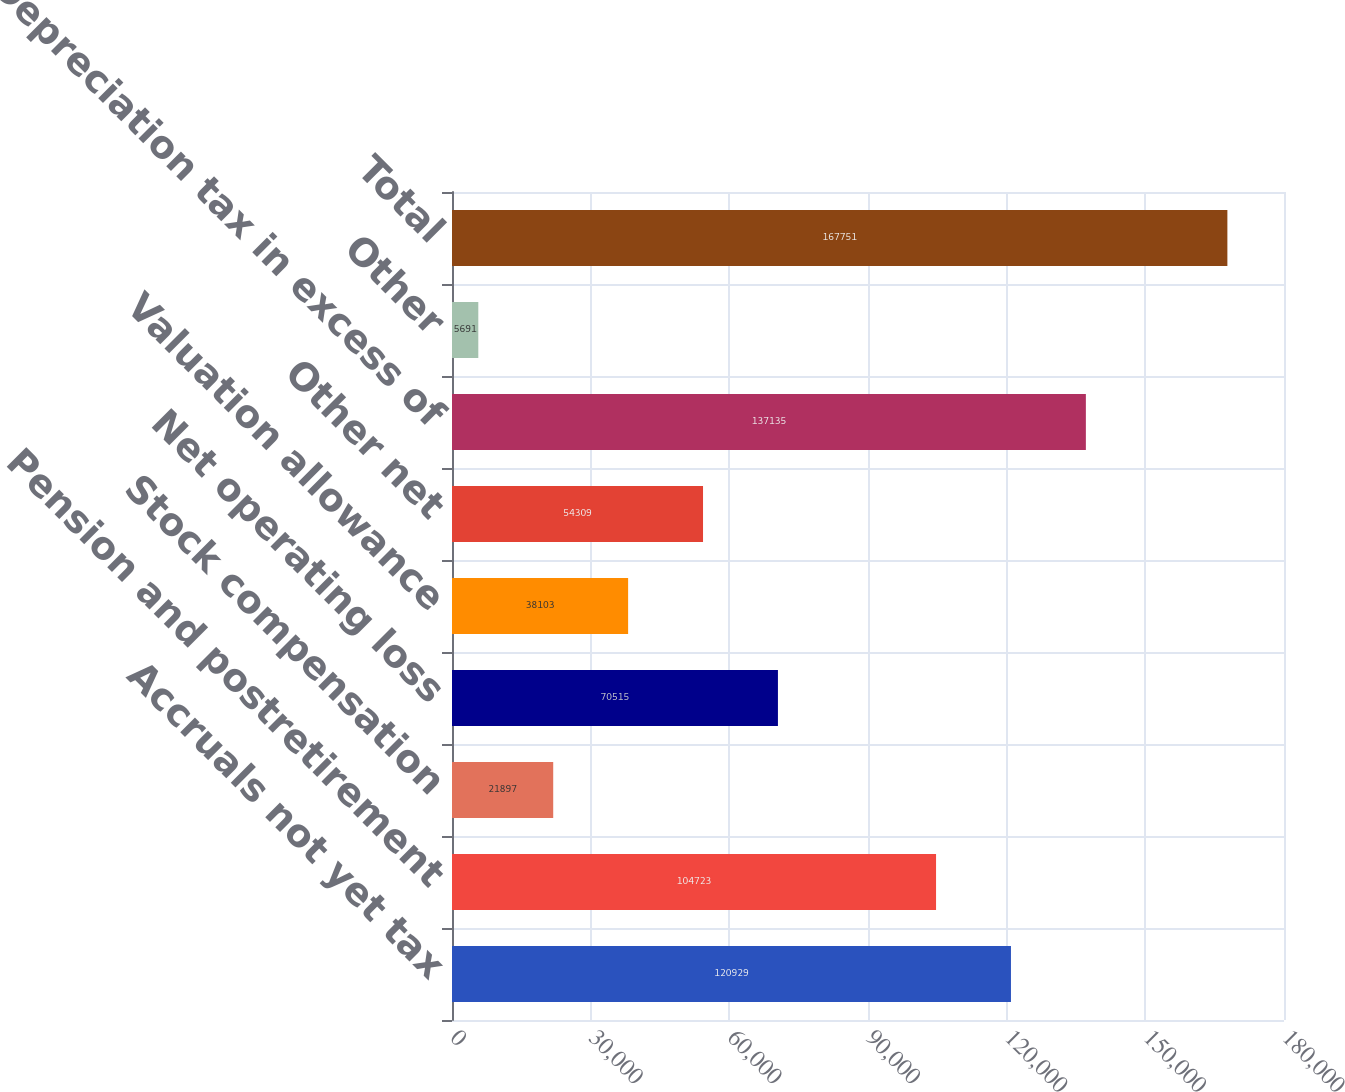Convert chart. <chart><loc_0><loc_0><loc_500><loc_500><bar_chart><fcel>Accruals not yet tax<fcel>Pension and postretirement<fcel>Stock compensation<fcel>Net operating loss<fcel>Valuation allowance<fcel>Other net<fcel>Depreciation tax in excess of<fcel>Other<fcel>Total<nl><fcel>120929<fcel>104723<fcel>21897<fcel>70515<fcel>38103<fcel>54309<fcel>137135<fcel>5691<fcel>167751<nl></chart> 